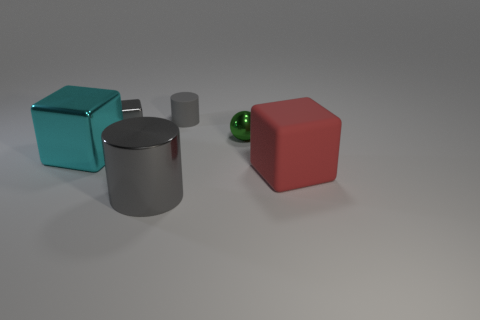Is there a matte block of the same size as the green thing? no 